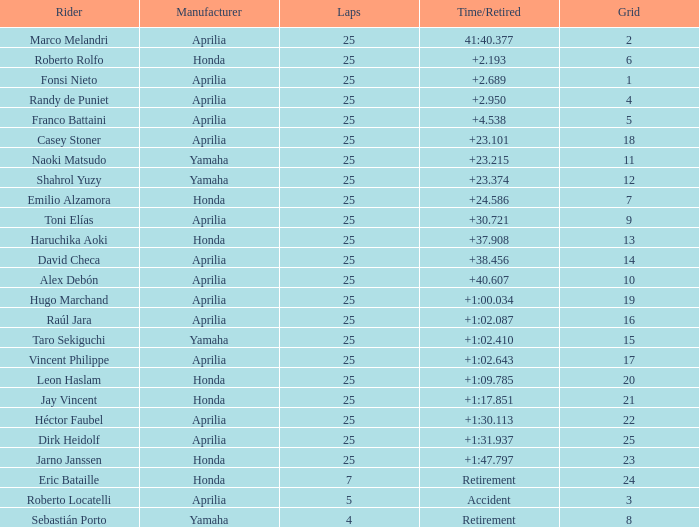Which Manufacturer has a Time/Retired of accident? Aprilia. 